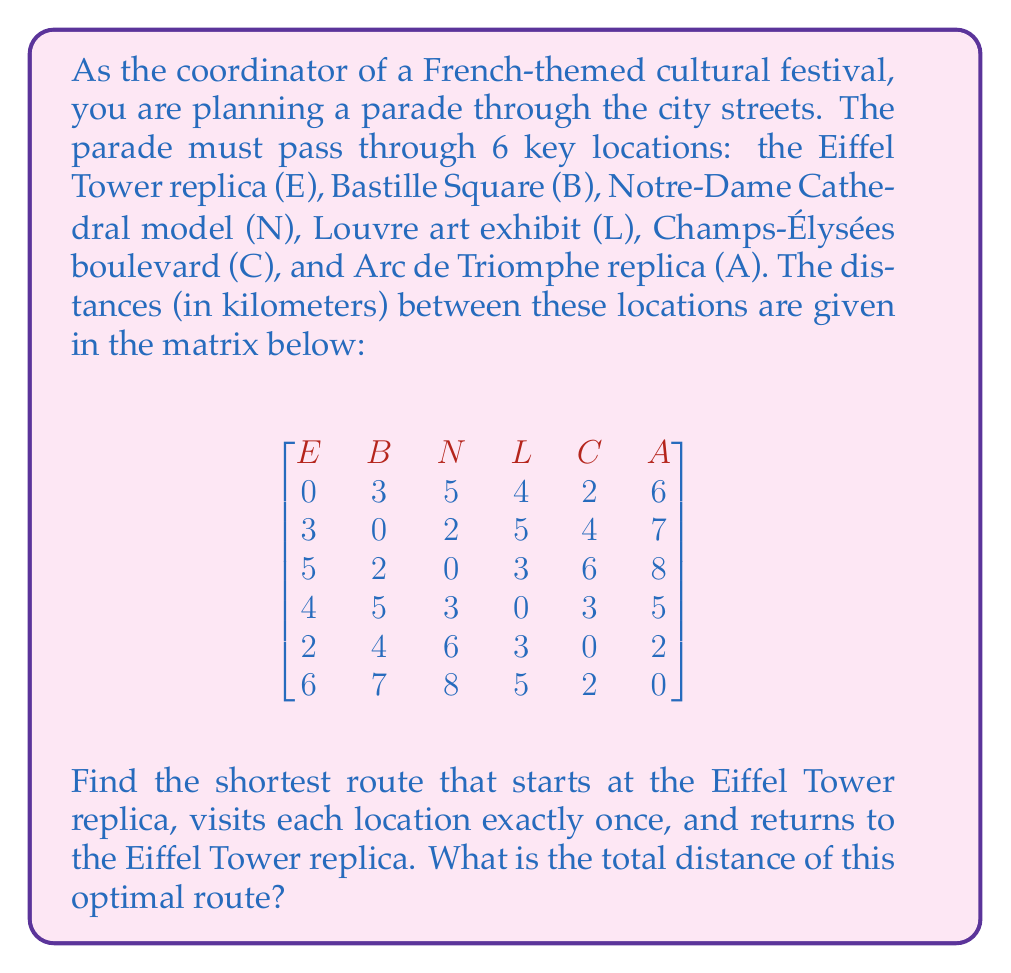Give your solution to this math problem. This problem is an instance of the Traveling Salesman Problem (TSP), which aims to find the shortest possible route that visits each city exactly once and returns to the starting point.

To solve this, we can use the following steps:

1) First, we need to list all possible routes starting and ending at E (Eiffel Tower replica). There are (5-1)! = 24 possible routes.

2) For each route, calculate the total distance:
   - Start with the distance from E to the first location
   - Add distances between consecutive locations
   - Add the distance from the last location back to E

3) Compare all route distances and select the shortest one.

Let's calculate a few routes as examples:

E-B-N-L-C-A-E: 3 + 2 + 3 + 3 + 2 + 6 = 19 km
E-B-N-L-A-C-E: 3 + 2 + 3 + 5 + 2 + 2 = 17 km
E-C-A-L-N-B-E: 2 + 2 + 5 + 3 + 2 + 3 = 17 km

After calculating all 24 routes, we find that the shortest route is:

E-C-A-L-N-B-E

The total distance of this route is:
$$2 + 2 + 5 + 3 + 2 + 3 = 17\text{ km}$$

This route minimizes the total distance while satisfying all the constraints of the problem.
Answer: The optimal route is E-C-A-L-N-B-E, with a total distance of 17 km. 